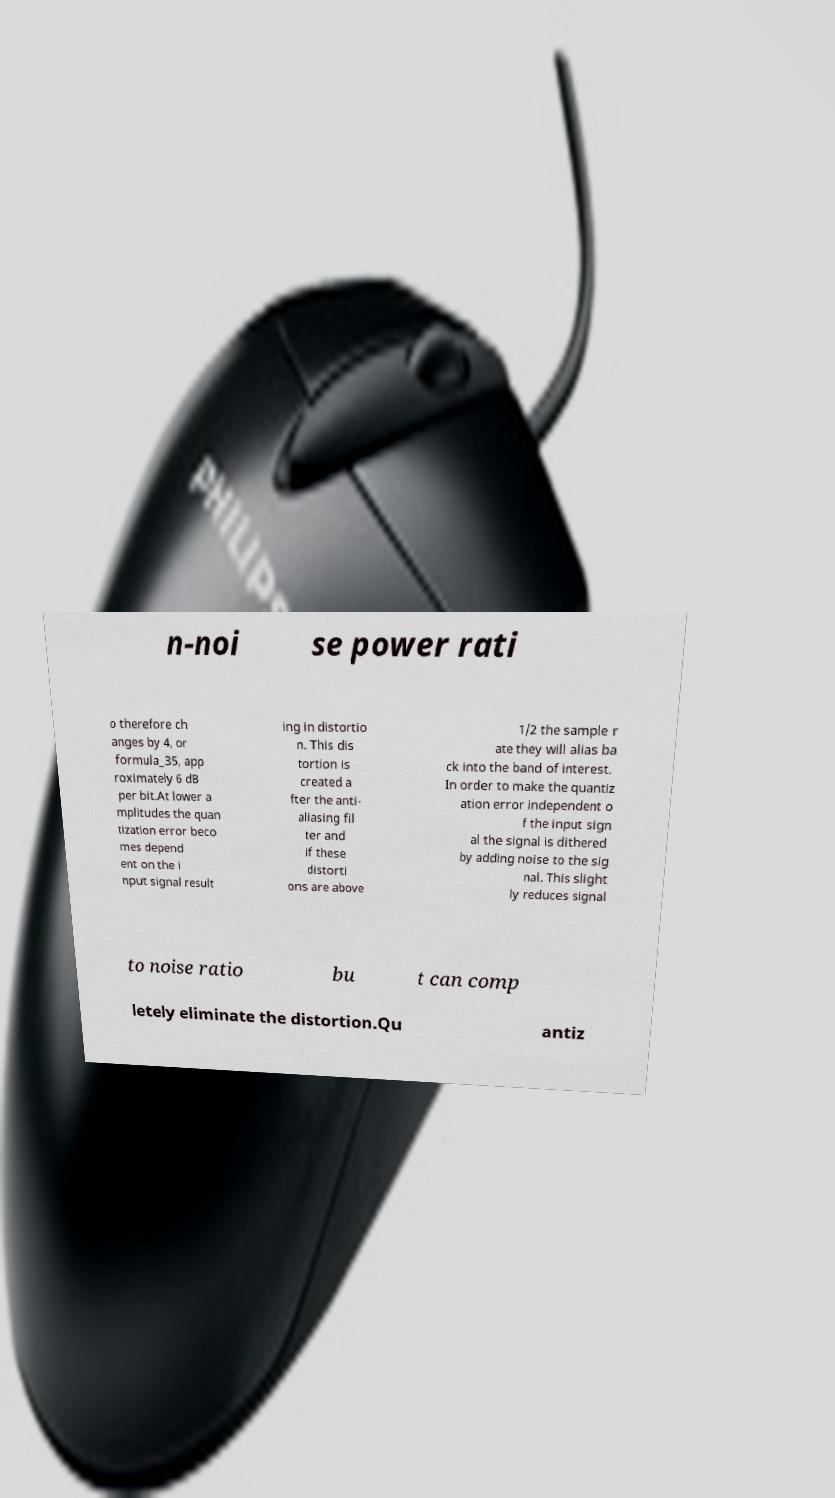Can you read and provide the text displayed in the image?This photo seems to have some interesting text. Can you extract and type it out for me? n-noi se power rati o therefore ch anges by 4, or formula_35, app roximately 6 dB per bit.At lower a mplitudes the quan tization error beco mes depend ent on the i nput signal result ing in distortio n. This dis tortion is created a fter the anti- aliasing fil ter and if these distorti ons are above 1/2 the sample r ate they will alias ba ck into the band of interest. In order to make the quantiz ation error independent o f the input sign al the signal is dithered by adding noise to the sig nal. This slight ly reduces signal to noise ratio bu t can comp letely eliminate the distortion.Qu antiz 